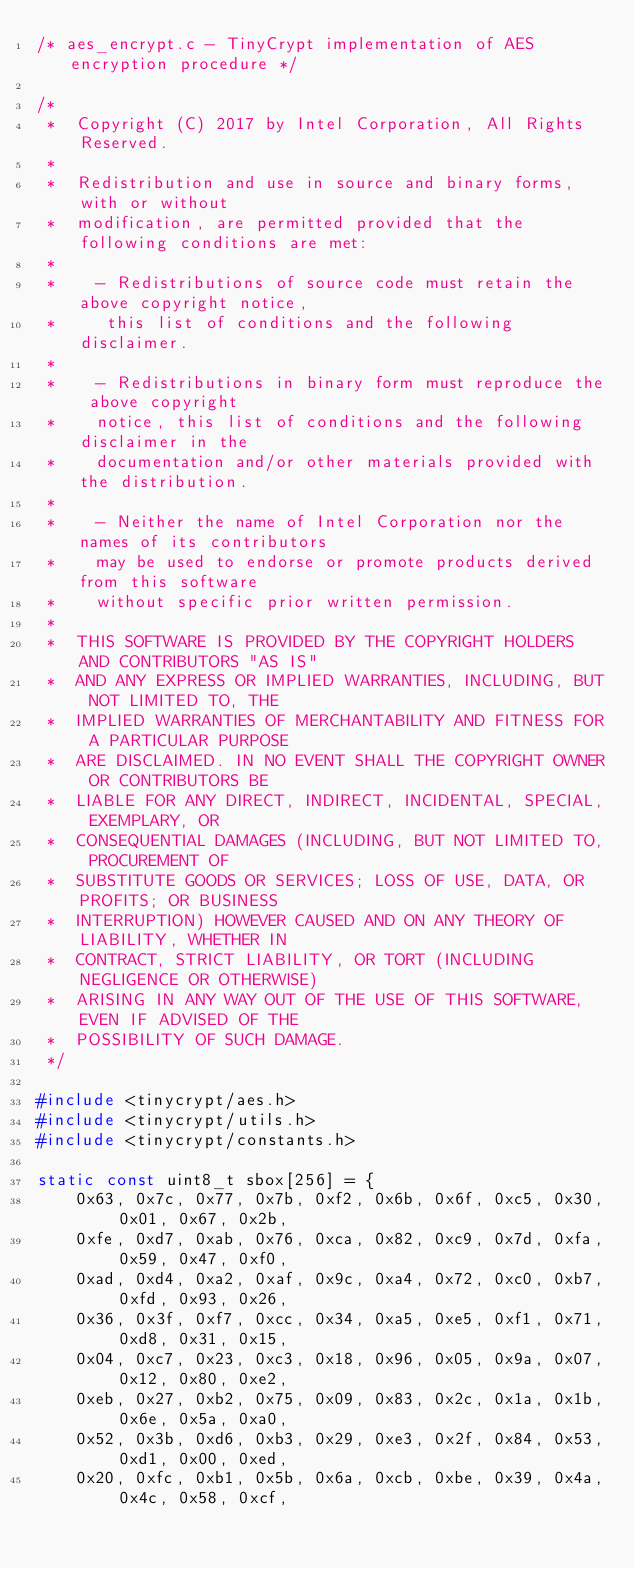<code> <loc_0><loc_0><loc_500><loc_500><_C_>/* aes_encrypt.c - TinyCrypt implementation of AES encryption procedure */

/*
 *  Copyright (C) 2017 by Intel Corporation, All Rights Reserved.
 *
 *  Redistribution and use in source and binary forms, with or without
 *  modification, are permitted provided that the following conditions are met:
 *
 *    - Redistributions of source code must retain the above copyright notice,
 *     this list of conditions and the following disclaimer.
 *
 *    - Redistributions in binary form must reproduce the above copyright
 *    notice, this list of conditions and the following disclaimer in the
 *    documentation and/or other materials provided with the distribution.
 *
 *    - Neither the name of Intel Corporation nor the names of its contributors
 *    may be used to endorse or promote products derived from this software
 *    without specific prior written permission.
 *
 *  THIS SOFTWARE IS PROVIDED BY THE COPYRIGHT HOLDERS AND CONTRIBUTORS "AS IS"
 *  AND ANY EXPRESS OR IMPLIED WARRANTIES, INCLUDING, BUT NOT LIMITED TO, THE
 *  IMPLIED WARRANTIES OF MERCHANTABILITY AND FITNESS FOR A PARTICULAR PURPOSE
 *  ARE DISCLAIMED. IN NO EVENT SHALL THE COPYRIGHT OWNER OR CONTRIBUTORS BE
 *  LIABLE FOR ANY DIRECT, INDIRECT, INCIDENTAL, SPECIAL, EXEMPLARY, OR
 *  CONSEQUENTIAL DAMAGES (INCLUDING, BUT NOT LIMITED TO, PROCUREMENT OF
 *  SUBSTITUTE GOODS OR SERVICES; LOSS OF USE, DATA, OR PROFITS; OR BUSINESS
 *  INTERRUPTION) HOWEVER CAUSED AND ON ANY THEORY OF LIABILITY, WHETHER IN
 *  CONTRACT, STRICT LIABILITY, OR TORT (INCLUDING NEGLIGENCE OR OTHERWISE)
 *  ARISING IN ANY WAY OUT OF THE USE OF THIS SOFTWARE, EVEN IF ADVISED OF THE
 *  POSSIBILITY OF SUCH DAMAGE.
 */

#include <tinycrypt/aes.h>
#include <tinycrypt/utils.h>
#include <tinycrypt/constants.h>

static const uint8_t sbox[256] = {
    0x63, 0x7c, 0x77, 0x7b, 0xf2, 0x6b, 0x6f, 0xc5, 0x30, 0x01, 0x67, 0x2b,
    0xfe, 0xd7, 0xab, 0x76, 0xca, 0x82, 0xc9, 0x7d, 0xfa, 0x59, 0x47, 0xf0,
    0xad, 0xd4, 0xa2, 0xaf, 0x9c, 0xa4, 0x72, 0xc0, 0xb7, 0xfd, 0x93, 0x26,
    0x36, 0x3f, 0xf7, 0xcc, 0x34, 0xa5, 0xe5, 0xf1, 0x71, 0xd8, 0x31, 0x15,
    0x04, 0xc7, 0x23, 0xc3, 0x18, 0x96, 0x05, 0x9a, 0x07, 0x12, 0x80, 0xe2,
    0xeb, 0x27, 0xb2, 0x75, 0x09, 0x83, 0x2c, 0x1a, 0x1b, 0x6e, 0x5a, 0xa0,
    0x52, 0x3b, 0xd6, 0xb3, 0x29, 0xe3, 0x2f, 0x84, 0x53, 0xd1, 0x00, 0xed,
    0x20, 0xfc, 0xb1, 0x5b, 0x6a, 0xcb, 0xbe, 0x39, 0x4a, 0x4c, 0x58, 0xcf,</code> 